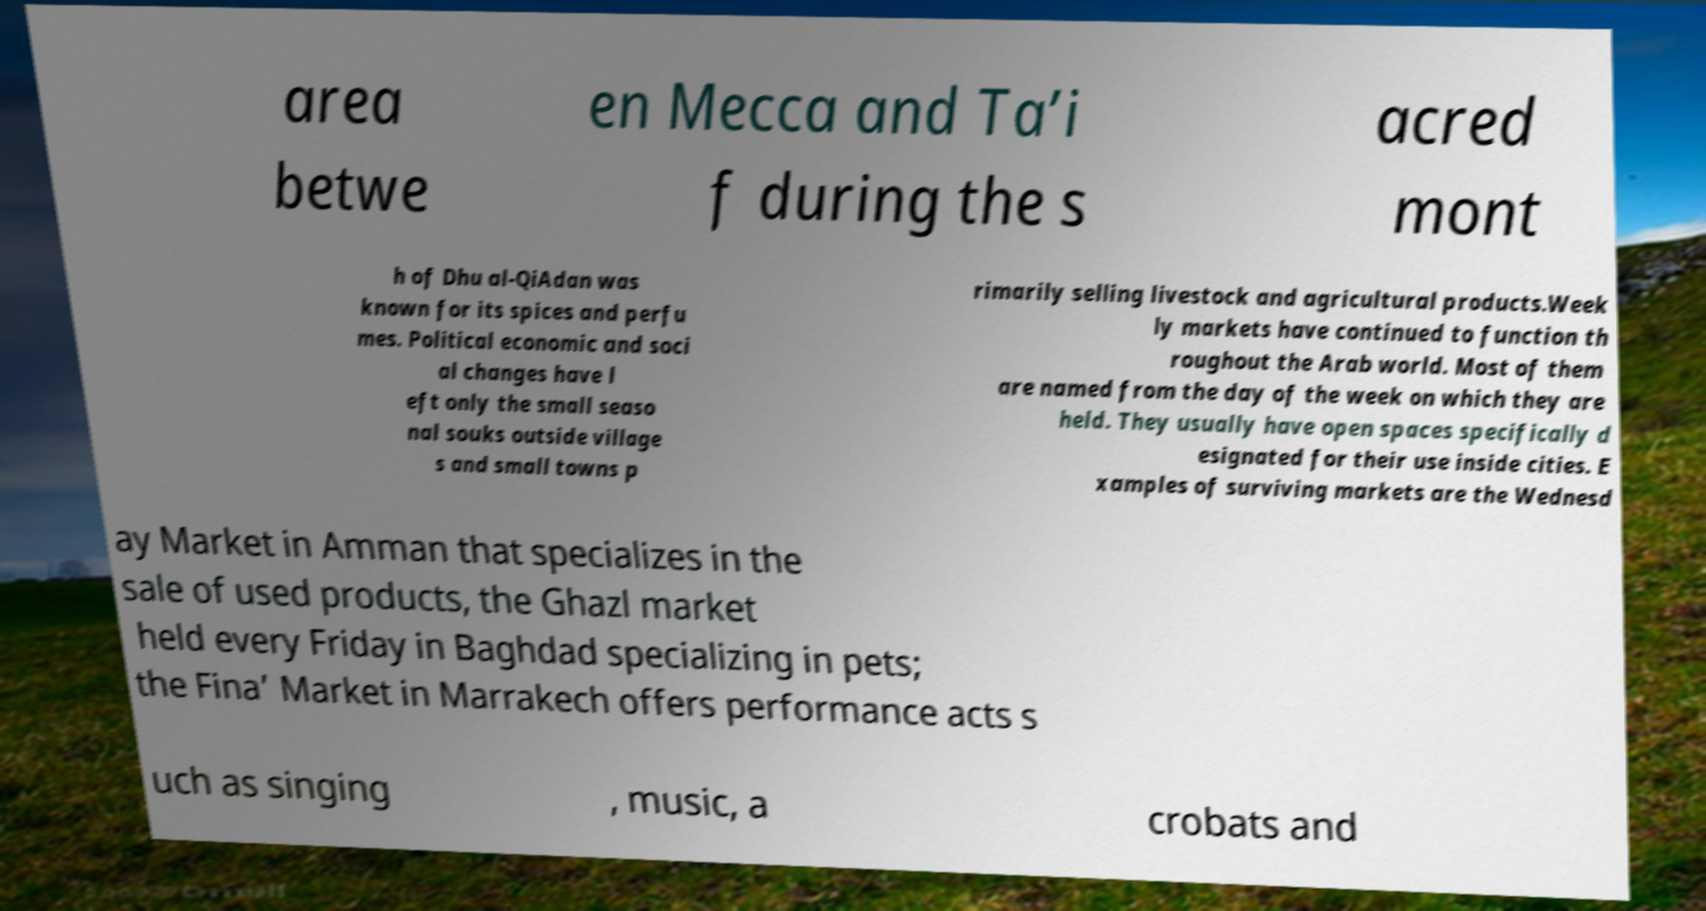Could you extract and type out the text from this image? area betwe en Mecca and Ta’i f during the s acred mont h of Dhu al-QiAdan was known for its spices and perfu mes. Political economic and soci al changes have l eft only the small seaso nal souks outside village s and small towns p rimarily selling livestock and agricultural products.Week ly markets have continued to function th roughout the Arab world. Most of them are named from the day of the week on which they are held. They usually have open spaces specifically d esignated for their use inside cities. E xamples of surviving markets are the Wednesd ay Market in Amman that specializes in the sale of used products, the Ghazl market held every Friday in Baghdad specializing in pets; the Fina’ Market in Marrakech offers performance acts s uch as singing , music, a crobats and 